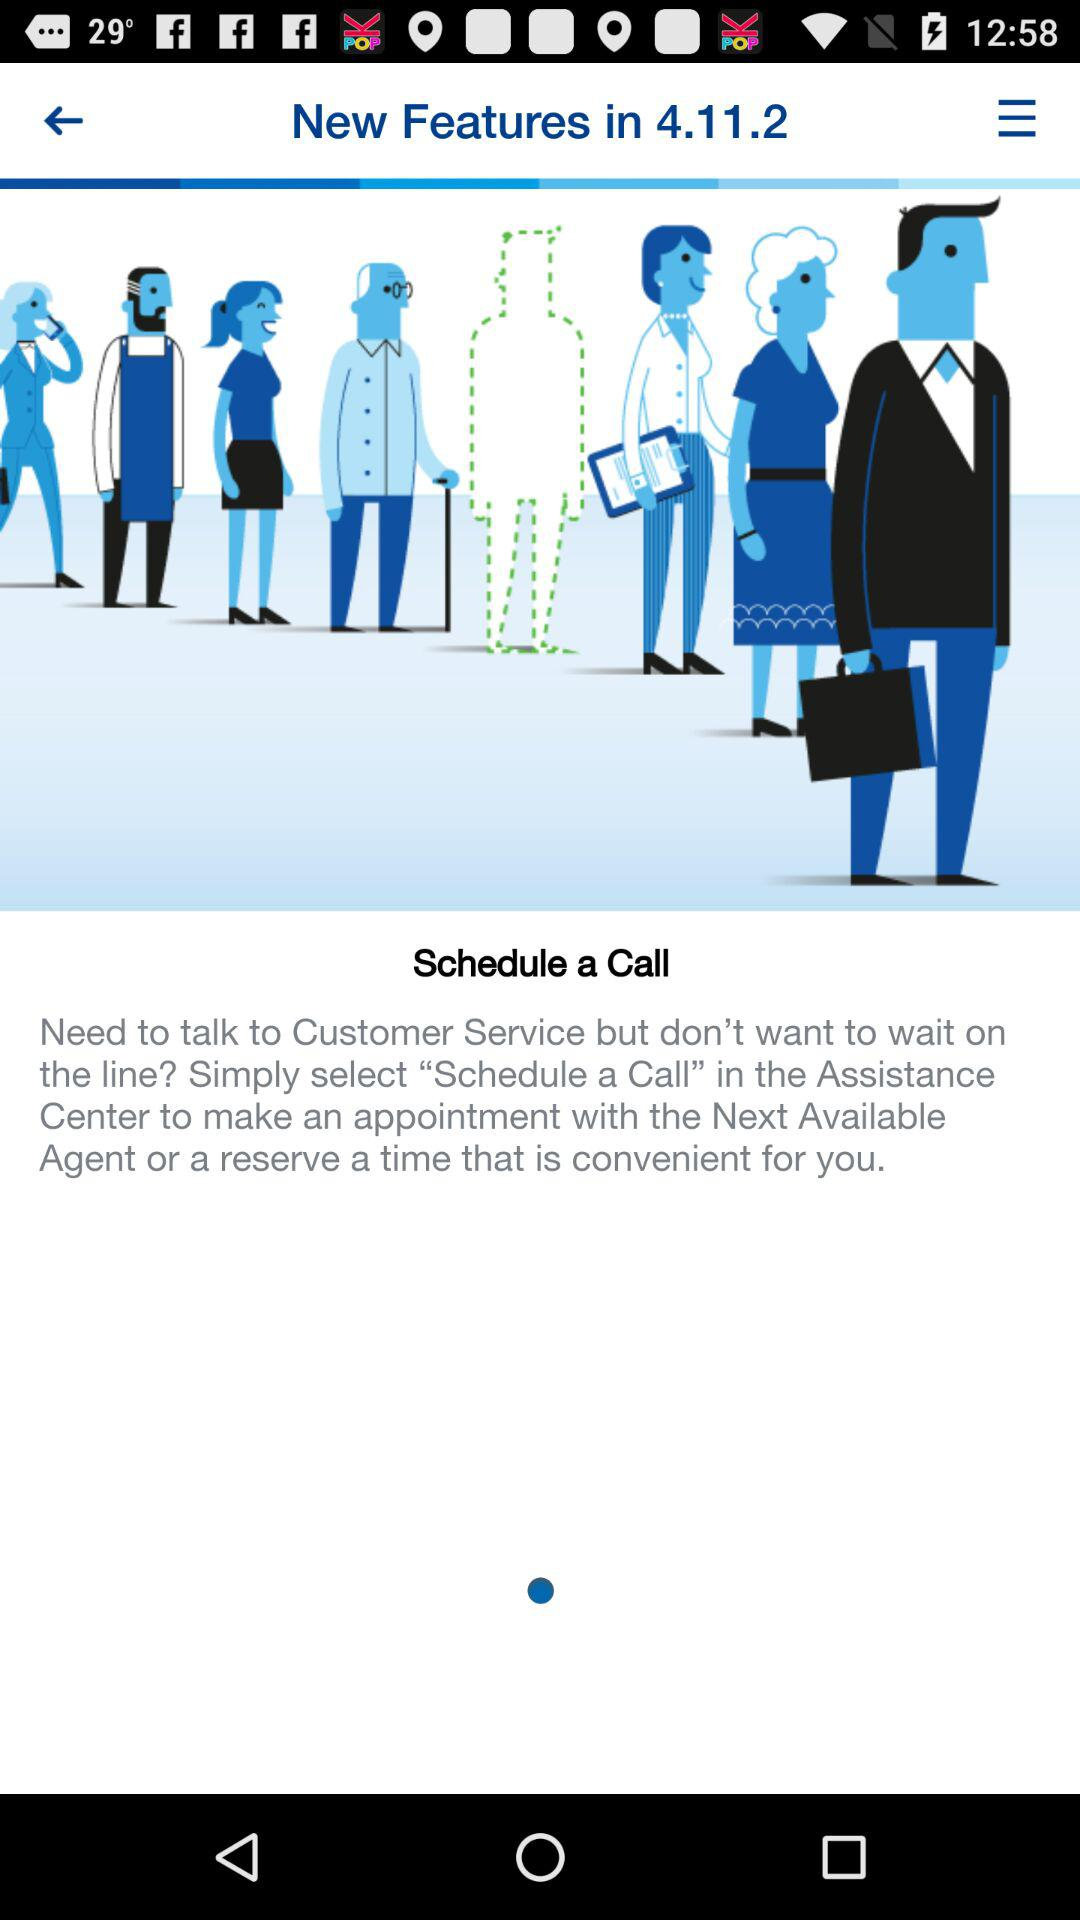What is the version number? The version number is 4.11.2. 